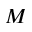Convert formula to latex. <formula><loc_0><loc_0><loc_500><loc_500>M</formula> 